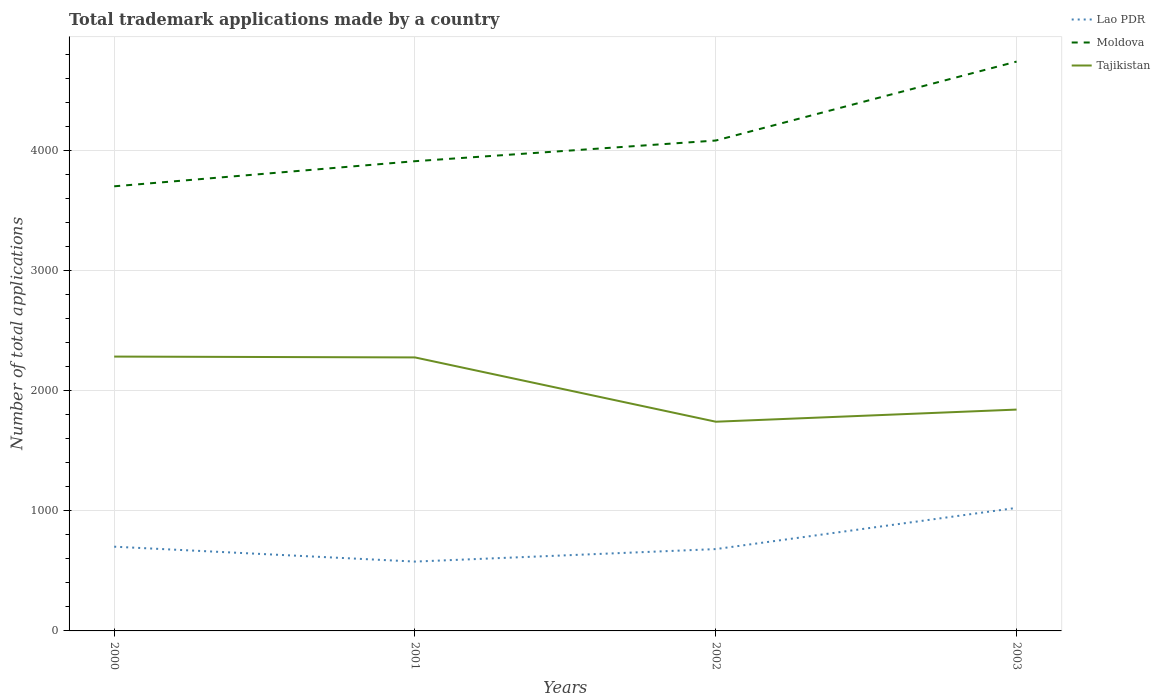Does the line corresponding to Lao PDR intersect with the line corresponding to Moldova?
Make the answer very short. No. Is the number of lines equal to the number of legend labels?
Your answer should be compact. Yes. Across all years, what is the maximum number of applications made by in Lao PDR?
Ensure brevity in your answer.  577. What is the total number of applications made by in Tajikistan in the graph?
Keep it short and to the point. 434. What is the difference between the highest and the second highest number of applications made by in Moldova?
Your answer should be very brief. 1038. What is the difference between the highest and the lowest number of applications made by in Lao PDR?
Your answer should be very brief. 1. Is the number of applications made by in Moldova strictly greater than the number of applications made by in Lao PDR over the years?
Your answer should be compact. No. How many years are there in the graph?
Offer a terse response. 4. What is the difference between two consecutive major ticks on the Y-axis?
Give a very brief answer. 1000. Does the graph contain grids?
Provide a succinct answer. Yes. How are the legend labels stacked?
Offer a terse response. Vertical. What is the title of the graph?
Offer a very short reply. Total trademark applications made by a country. Does "Israel" appear as one of the legend labels in the graph?
Your answer should be compact. No. What is the label or title of the X-axis?
Offer a very short reply. Years. What is the label or title of the Y-axis?
Keep it short and to the point. Number of total applications. What is the Number of total applications in Lao PDR in 2000?
Offer a terse response. 701. What is the Number of total applications in Moldova in 2000?
Keep it short and to the point. 3700. What is the Number of total applications of Tajikistan in 2000?
Offer a very short reply. 2283. What is the Number of total applications of Lao PDR in 2001?
Give a very brief answer. 577. What is the Number of total applications in Moldova in 2001?
Your answer should be very brief. 3909. What is the Number of total applications of Tajikistan in 2001?
Offer a terse response. 2276. What is the Number of total applications in Lao PDR in 2002?
Offer a very short reply. 681. What is the Number of total applications in Moldova in 2002?
Offer a very short reply. 4081. What is the Number of total applications in Tajikistan in 2002?
Your response must be concise. 1741. What is the Number of total applications of Lao PDR in 2003?
Make the answer very short. 1024. What is the Number of total applications of Moldova in 2003?
Offer a very short reply. 4738. What is the Number of total applications of Tajikistan in 2003?
Keep it short and to the point. 1842. Across all years, what is the maximum Number of total applications in Lao PDR?
Give a very brief answer. 1024. Across all years, what is the maximum Number of total applications in Moldova?
Provide a short and direct response. 4738. Across all years, what is the maximum Number of total applications of Tajikistan?
Ensure brevity in your answer.  2283. Across all years, what is the minimum Number of total applications in Lao PDR?
Offer a terse response. 577. Across all years, what is the minimum Number of total applications of Moldova?
Your answer should be very brief. 3700. Across all years, what is the minimum Number of total applications of Tajikistan?
Provide a succinct answer. 1741. What is the total Number of total applications of Lao PDR in the graph?
Provide a succinct answer. 2983. What is the total Number of total applications in Moldova in the graph?
Make the answer very short. 1.64e+04. What is the total Number of total applications of Tajikistan in the graph?
Your answer should be compact. 8142. What is the difference between the Number of total applications in Lao PDR in 2000 and that in 2001?
Your answer should be compact. 124. What is the difference between the Number of total applications in Moldova in 2000 and that in 2001?
Keep it short and to the point. -209. What is the difference between the Number of total applications of Lao PDR in 2000 and that in 2002?
Ensure brevity in your answer.  20. What is the difference between the Number of total applications in Moldova in 2000 and that in 2002?
Your answer should be very brief. -381. What is the difference between the Number of total applications in Tajikistan in 2000 and that in 2002?
Make the answer very short. 542. What is the difference between the Number of total applications of Lao PDR in 2000 and that in 2003?
Offer a very short reply. -323. What is the difference between the Number of total applications in Moldova in 2000 and that in 2003?
Your response must be concise. -1038. What is the difference between the Number of total applications of Tajikistan in 2000 and that in 2003?
Provide a short and direct response. 441. What is the difference between the Number of total applications in Lao PDR in 2001 and that in 2002?
Your response must be concise. -104. What is the difference between the Number of total applications in Moldova in 2001 and that in 2002?
Your answer should be compact. -172. What is the difference between the Number of total applications of Tajikistan in 2001 and that in 2002?
Keep it short and to the point. 535. What is the difference between the Number of total applications in Lao PDR in 2001 and that in 2003?
Provide a short and direct response. -447. What is the difference between the Number of total applications in Moldova in 2001 and that in 2003?
Offer a terse response. -829. What is the difference between the Number of total applications of Tajikistan in 2001 and that in 2003?
Make the answer very short. 434. What is the difference between the Number of total applications in Lao PDR in 2002 and that in 2003?
Provide a succinct answer. -343. What is the difference between the Number of total applications of Moldova in 2002 and that in 2003?
Make the answer very short. -657. What is the difference between the Number of total applications of Tajikistan in 2002 and that in 2003?
Make the answer very short. -101. What is the difference between the Number of total applications of Lao PDR in 2000 and the Number of total applications of Moldova in 2001?
Provide a succinct answer. -3208. What is the difference between the Number of total applications in Lao PDR in 2000 and the Number of total applications in Tajikistan in 2001?
Provide a short and direct response. -1575. What is the difference between the Number of total applications in Moldova in 2000 and the Number of total applications in Tajikistan in 2001?
Provide a short and direct response. 1424. What is the difference between the Number of total applications in Lao PDR in 2000 and the Number of total applications in Moldova in 2002?
Offer a terse response. -3380. What is the difference between the Number of total applications of Lao PDR in 2000 and the Number of total applications of Tajikistan in 2002?
Your response must be concise. -1040. What is the difference between the Number of total applications of Moldova in 2000 and the Number of total applications of Tajikistan in 2002?
Your answer should be very brief. 1959. What is the difference between the Number of total applications in Lao PDR in 2000 and the Number of total applications in Moldova in 2003?
Offer a terse response. -4037. What is the difference between the Number of total applications of Lao PDR in 2000 and the Number of total applications of Tajikistan in 2003?
Your answer should be compact. -1141. What is the difference between the Number of total applications in Moldova in 2000 and the Number of total applications in Tajikistan in 2003?
Your answer should be very brief. 1858. What is the difference between the Number of total applications of Lao PDR in 2001 and the Number of total applications of Moldova in 2002?
Provide a succinct answer. -3504. What is the difference between the Number of total applications in Lao PDR in 2001 and the Number of total applications in Tajikistan in 2002?
Make the answer very short. -1164. What is the difference between the Number of total applications in Moldova in 2001 and the Number of total applications in Tajikistan in 2002?
Provide a succinct answer. 2168. What is the difference between the Number of total applications of Lao PDR in 2001 and the Number of total applications of Moldova in 2003?
Offer a terse response. -4161. What is the difference between the Number of total applications of Lao PDR in 2001 and the Number of total applications of Tajikistan in 2003?
Provide a succinct answer. -1265. What is the difference between the Number of total applications in Moldova in 2001 and the Number of total applications in Tajikistan in 2003?
Provide a succinct answer. 2067. What is the difference between the Number of total applications of Lao PDR in 2002 and the Number of total applications of Moldova in 2003?
Keep it short and to the point. -4057. What is the difference between the Number of total applications of Lao PDR in 2002 and the Number of total applications of Tajikistan in 2003?
Provide a succinct answer. -1161. What is the difference between the Number of total applications in Moldova in 2002 and the Number of total applications in Tajikistan in 2003?
Make the answer very short. 2239. What is the average Number of total applications in Lao PDR per year?
Make the answer very short. 745.75. What is the average Number of total applications of Moldova per year?
Keep it short and to the point. 4107. What is the average Number of total applications in Tajikistan per year?
Keep it short and to the point. 2035.5. In the year 2000, what is the difference between the Number of total applications of Lao PDR and Number of total applications of Moldova?
Make the answer very short. -2999. In the year 2000, what is the difference between the Number of total applications in Lao PDR and Number of total applications in Tajikistan?
Provide a short and direct response. -1582. In the year 2000, what is the difference between the Number of total applications of Moldova and Number of total applications of Tajikistan?
Offer a very short reply. 1417. In the year 2001, what is the difference between the Number of total applications of Lao PDR and Number of total applications of Moldova?
Your answer should be very brief. -3332. In the year 2001, what is the difference between the Number of total applications in Lao PDR and Number of total applications in Tajikistan?
Make the answer very short. -1699. In the year 2001, what is the difference between the Number of total applications in Moldova and Number of total applications in Tajikistan?
Ensure brevity in your answer.  1633. In the year 2002, what is the difference between the Number of total applications in Lao PDR and Number of total applications in Moldova?
Your answer should be very brief. -3400. In the year 2002, what is the difference between the Number of total applications in Lao PDR and Number of total applications in Tajikistan?
Your answer should be very brief. -1060. In the year 2002, what is the difference between the Number of total applications of Moldova and Number of total applications of Tajikistan?
Your answer should be compact. 2340. In the year 2003, what is the difference between the Number of total applications of Lao PDR and Number of total applications of Moldova?
Ensure brevity in your answer.  -3714. In the year 2003, what is the difference between the Number of total applications in Lao PDR and Number of total applications in Tajikistan?
Your answer should be compact. -818. In the year 2003, what is the difference between the Number of total applications in Moldova and Number of total applications in Tajikistan?
Make the answer very short. 2896. What is the ratio of the Number of total applications in Lao PDR in 2000 to that in 2001?
Provide a short and direct response. 1.21. What is the ratio of the Number of total applications of Moldova in 2000 to that in 2001?
Provide a succinct answer. 0.95. What is the ratio of the Number of total applications in Lao PDR in 2000 to that in 2002?
Ensure brevity in your answer.  1.03. What is the ratio of the Number of total applications in Moldova in 2000 to that in 2002?
Keep it short and to the point. 0.91. What is the ratio of the Number of total applications of Tajikistan in 2000 to that in 2002?
Your response must be concise. 1.31. What is the ratio of the Number of total applications in Lao PDR in 2000 to that in 2003?
Ensure brevity in your answer.  0.68. What is the ratio of the Number of total applications in Moldova in 2000 to that in 2003?
Ensure brevity in your answer.  0.78. What is the ratio of the Number of total applications in Tajikistan in 2000 to that in 2003?
Offer a terse response. 1.24. What is the ratio of the Number of total applications of Lao PDR in 2001 to that in 2002?
Offer a very short reply. 0.85. What is the ratio of the Number of total applications in Moldova in 2001 to that in 2002?
Make the answer very short. 0.96. What is the ratio of the Number of total applications of Tajikistan in 2001 to that in 2002?
Offer a very short reply. 1.31. What is the ratio of the Number of total applications of Lao PDR in 2001 to that in 2003?
Provide a short and direct response. 0.56. What is the ratio of the Number of total applications in Moldova in 2001 to that in 2003?
Ensure brevity in your answer.  0.82. What is the ratio of the Number of total applications in Tajikistan in 2001 to that in 2003?
Your response must be concise. 1.24. What is the ratio of the Number of total applications of Lao PDR in 2002 to that in 2003?
Keep it short and to the point. 0.67. What is the ratio of the Number of total applications in Moldova in 2002 to that in 2003?
Offer a terse response. 0.86. What is the ratio of the Number of total applications of Tajikistan in 2002 to that in 2003?
Your answer should be very brief. 0.95. What is the difference between the highest and the second highest Number of total applications of Lao PDR?
Provide a succinct answer. 323. What is the difference between the highest and the second highest Number of total applications of Moldova?
Make the answer very short. 657. What is the difference between the highest and the second highest Number of total applications of Tajikistan?
Provide a short and direct response. 7. What is the difference between the highest and the lowest Number of total applications of Lao PDR?
Provide a short and direct response. 447. What is the difference between the highest and the lowest Number of total applications of Moldova?
Provide a succinct answer. 1038. What is the difference between the highest and the lowest Number of total applications in Tajikistan?
Give a very brief answer. 542. 